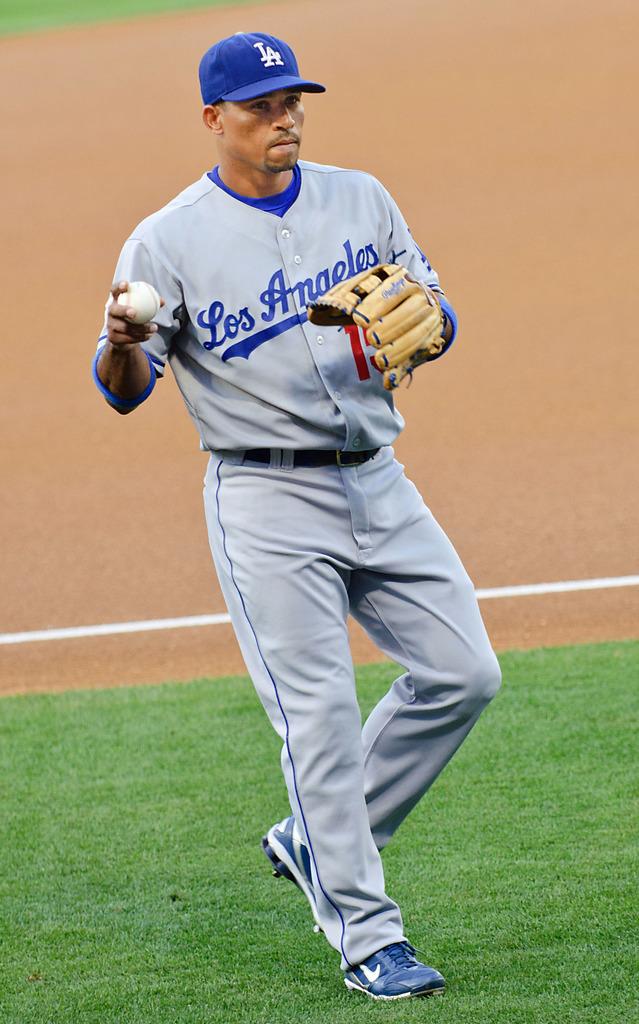What team/state does the player play for?
Your answer should be very brief. Los angeles. What is the mark of his shoes?
Your response must be concise. Answering does not require reading text in the image. 